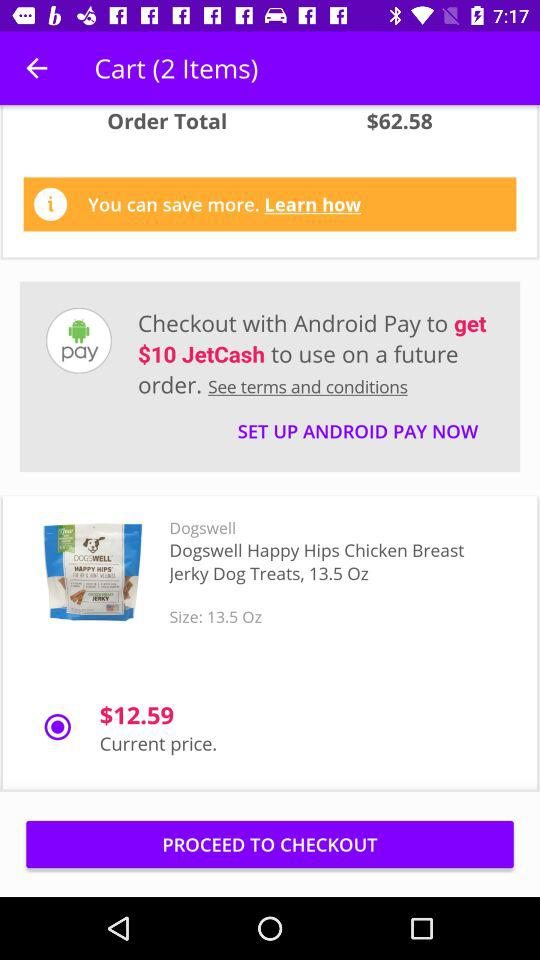What is the current price? The current price is $12.59. 